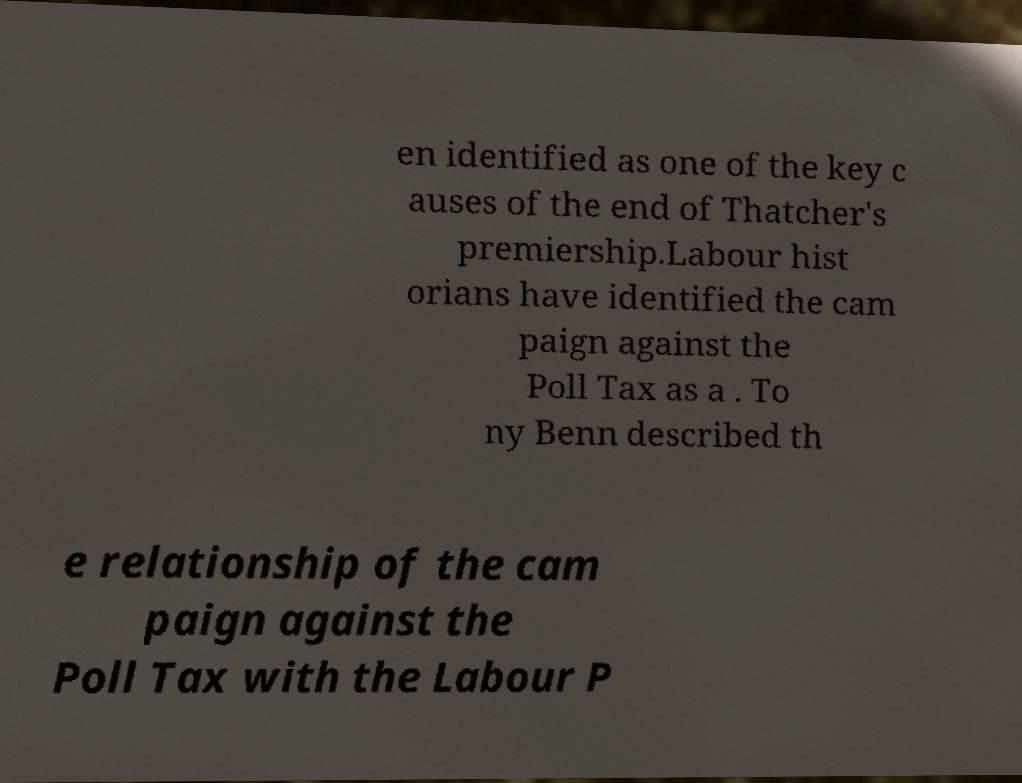Could you extract and type out the text from this image? en identified as one of the key c auses of the end of Thatcher's premiership.Labour hist orians have identified the cam paign against the Poll Tax as a . To ny Benn described th e relationship of the cam paign against the Poll Tax with the Labour P 